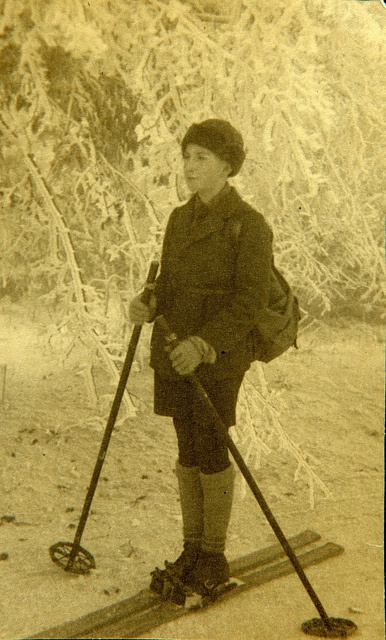Describe the objects in this image and their specific colors. I can see people in tan, olive, and black tones, skis in tan and olive tones, and backpack in tan, olive, and black tones in this image. 